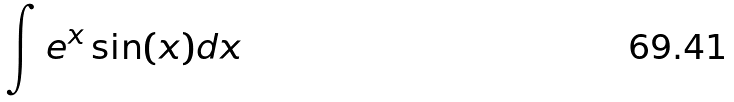<formula> <loc_0><loc_0><loc_500><loc_500>\int e ^ { x } \sin ( x ) d x</formula> 